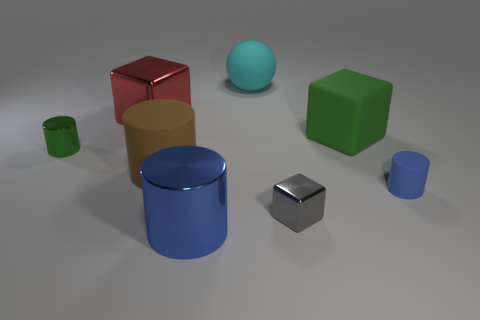Are there an equal number of large red cubes that are in front of the tiny green cylinder and green things that are to the right of the large blue metal cylinder?
Give a very brief answer. No. There is a large thing to the right of the matte ball; does it have the same shape as the shiny object left of the large red object?
Keep it short and to the point. No. Are there any other things that have the same shape as the gray metallic thing?
Your answer should be compact. Yes. There is a tiny gray thing that is made of the same material as the big red cube; what shape is it?
Your response must be concise. Cube. Is the number of tiny cylinders to the left of the brown cylinder the same as the number of small brown blocks?
Ensure brevity in your answer.  No. Are the green thing that is on the right side of the green cylinder and the tiny blue cylinder that is on the right side of the cyan sphere made of the same material?
Your answer should be very brief. Yes. There is a tiny object that is in front of the tiny matte thing to the right of the big green rubber thing; what is its shape?
Ensure brevity in your answer.  Cube. There is a sphere that is made of the same material as the brown cylinder; what is its color?
Make the answer very short. Cyan. Is the big sphere the same color as the big metal cylinder?
Give a very brief answer. No. There is a green thing that is the same size as the gray metal thing; what is its shape?
Your answer should be compact. Cylinder. 